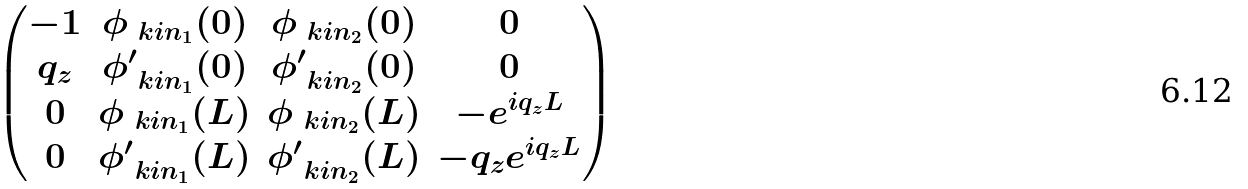<formula> <loc_0><loc_0><loc_500><loc_500>\begin{pmatrix} - 1 & \phi _ { \ k i n _ { 1 } } ( 0 ) & \phi _ { \ k i n _ { 2 } } ( 0 ) & 0 \\ q _ { z } & \phi ^ { \prime } _ { \ k i n _ { 1 } } ( 0 ) & \phi ^ { \prime } _ { \ k i n _ { 2 } } ( 0 ) & 0 \\ 0 & \phi _ { \ k i n _ { 1 } } ( L ) & \phi _ { \ k i n _ { 2 } } ( L ) & - e ^ { i q _ { z } L } \\ 0 & \phi ^ { \prime } _ { \ k i n _ { 1 } } ( L ) & \phi ^ { \prime } _ { \ k i n _ { 2 } } ( L ) & - q _ { z } e ^ { i q _ { z } L } \end{pmatrix}</formula> 